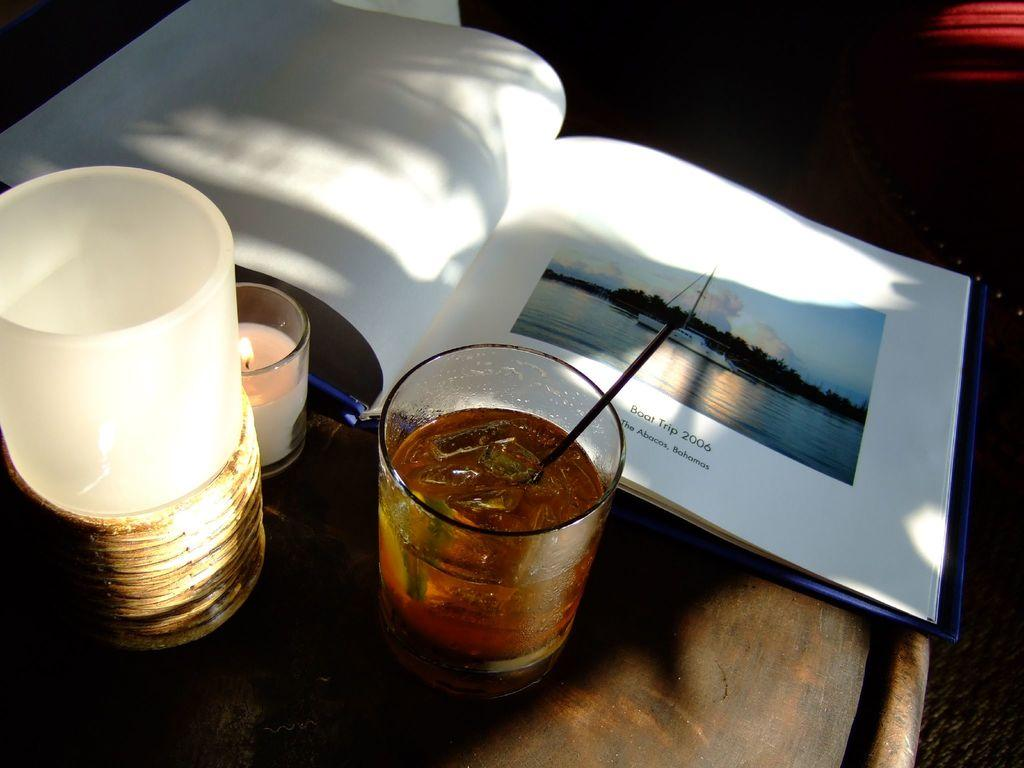<image>
Relay a brief, clear account of the picture shown. An book open to a page that says Boat Trip 2006 The Abacos, Bahamas laying next to a candle and a drink on a table, 